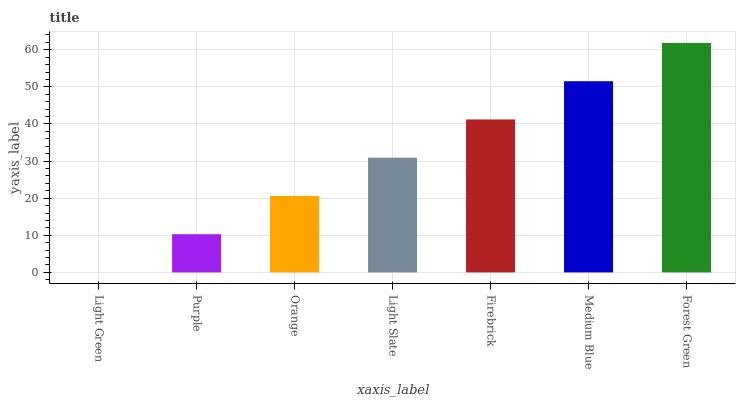Is Light Green the minimum?
Answer yes or no. Yes. Is Forest Green the maximum?
Answer yes or no. Yes. Is Purple the minimum?
Answer yes or no. No. Is Purple the maximum?
Answer yes or no. No. Is Purple greater than Light Green?
Answer yes or no. Yes. Is Light Green less than Purple?
Answer yes or no. Yes. Is Light Green greater than Purple?
Answer yes or no. No. Is Purple less than Light Green?
Answer yes or no. No. Is Light Slate the high median?
Answer yes or no. Yes. Is Light Slate the low median?
Answer yes or no. Yes. Is Light Green the high median?
Answer yes or no. No. Is Light Green the low median?
Answer yes or no. No. 